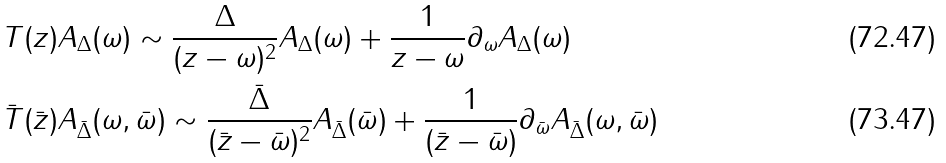<formula> <loc_0><loc_0><loc_500><loc_500>& T ( z ) A _ { \Delta } ( \omega ) \sim \frac { \Delta } { ( z - \omega ) ^ { 2 } } A _ { \Delta } ( \omega ) + \frac { 1 } { z - \omega } \partial _ { \omega } A _ { \Delta } ( \omega ) \\ & \bar { T } ( \bar { z } ) A _ { \bar { \Delta } } ( \omega , \bar { \omega } ) \sim \frac { \bar { \Delta } } { ( \bar { z } - \bar { \omega } ) ^ { 2 } } A _ { \bar { \Delta } } ( \bar { \omega } ) + \frac { 1 } { ( \bar { z } - \bar { \omega } ) } \partial _ { \bar { \omega } } A _ { \bar { \Delta } } ( \omega , \bar { \omega } )</formula> 